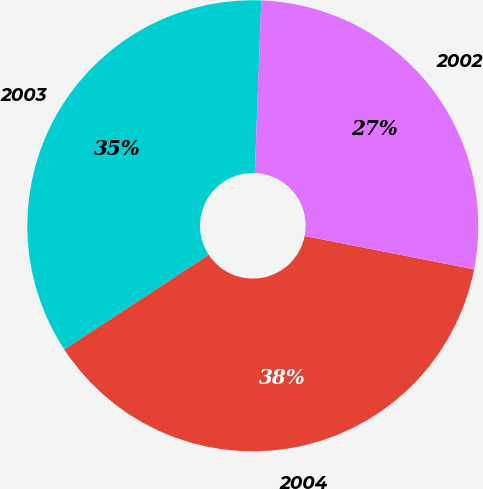<chart> <loc_0><loc_0><loc_500><loc_500><pie_chart><fcel>2004<fcel>2003<fcel>2002<nl><fcel>37.67%<fcel>34.83%<fcel>27.49%<nl></chart> 